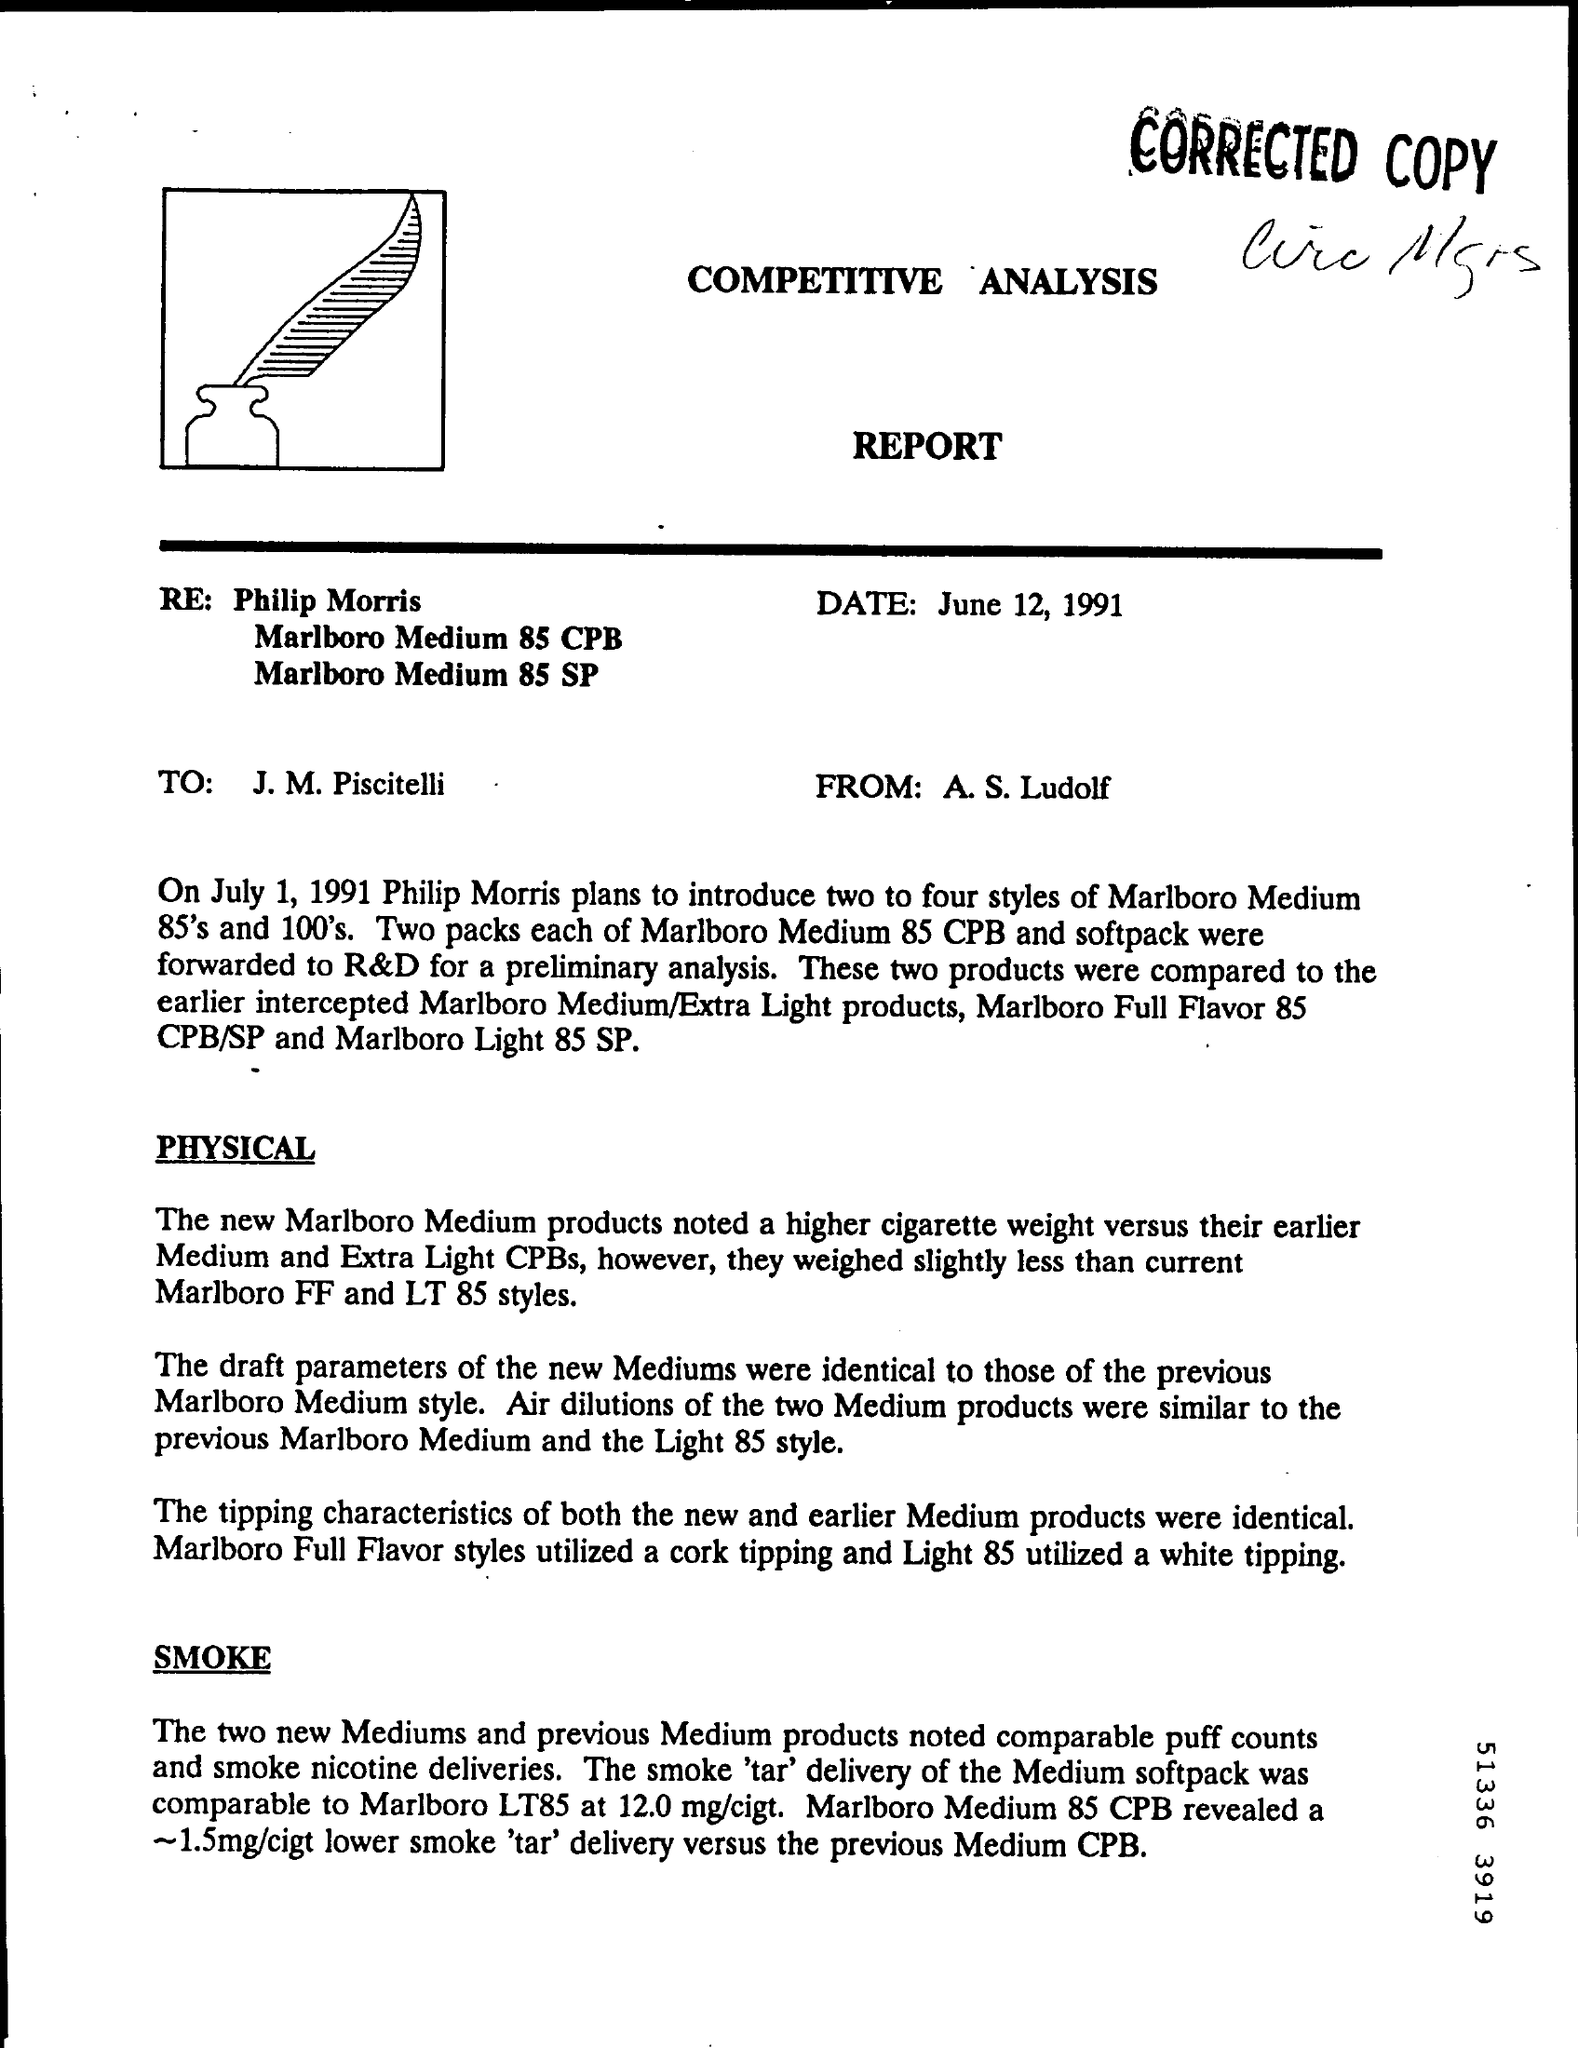When is the REPORT dated?
Your answer should be very brief. June 12, 1991. From whom is the report?
Your answer should be compact. A. S. Ludolf. To whom is the report addressed?
Ensure brevity in your answer.  J. M. piscitelli. 